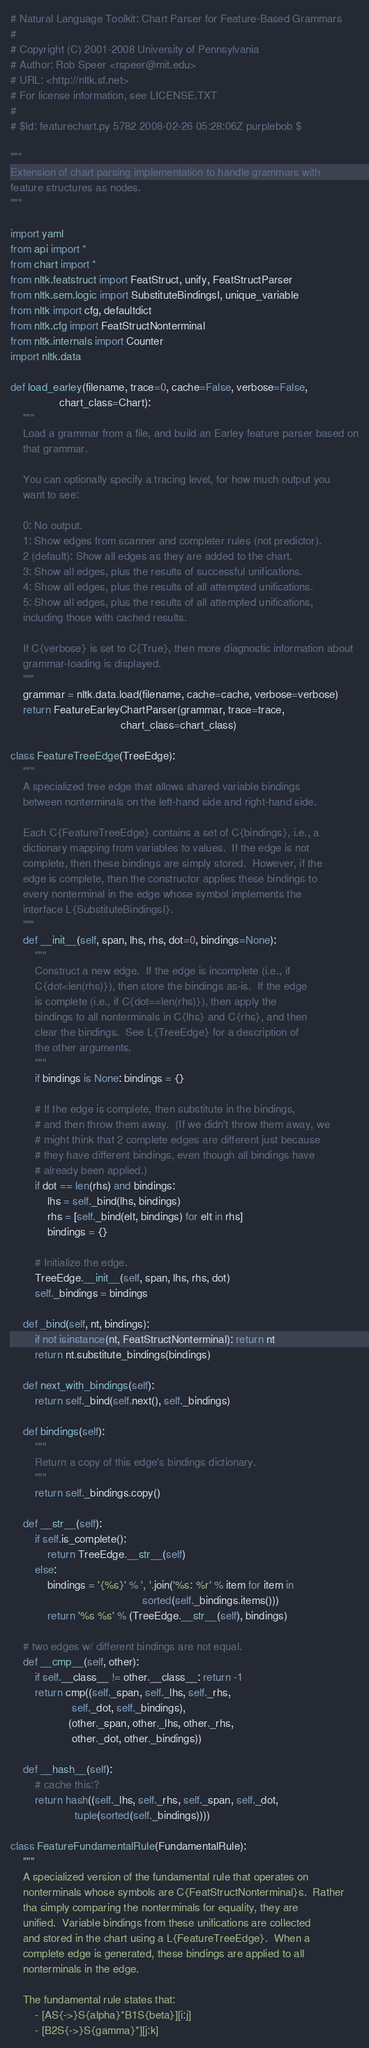<code> <loc_0><loc_0><loc_500><loc_500><_Python_># Natural Language Toolkit: Chart Parser for Feature-Based Grammars
#
# Copyright (C) 2001-2008 University of Pennsylvania
# Author: Rob Speer <rspeer@mit.edu>
# URL: <http://nltk.sf.net>
# For license information, see LICENSE.TXT
#
# $Id: featurechart.py 5782 2008-02-26 05:28:06Z purplebob $

"""
Extension of chart parsing implementation to handle grammars with
feature structures as nodes.
"""

import yaml
from api import *
from chart import *
from nltk.featstruct import FeatStruct, unify, FeatStructParser
from nltk.sem.logic import SubstituteBindingsI, unique_variable
from nltk import cfg, defaultdict
from nltk.cfg import FeatStructNonterminal
from nltk.internals import Counter
import nltk.data

def load_earley(filename, trace=0, cache=False, verbose=False,
                chart_class=Chart):
    """
    Load a grammar from a file, and build an Earley feature parser based on
    that grammar.

    You can optionally specify a tracing level, for how much output you
    want to see:

    0: No output.
    1: Show edges from scanner and completer rules (not predictor).
    2 (default): Show all edges as they are added to the chart.
    3: Show all edges, plus the results of successful unifications.
    4: Show all edges, plus the results of all attempted unifications.
    5: Show all edges, plus the results of all attempted unifications,
    including those with cached results.

    If C{verbose} is set to C{True}, then more diagnostic information about
    grammar-loading is displayed.
    """
    grammar = nltk.data.load(filename, cache=cache, verbose=verbose)
    return FeatureEarleyChartParser(grammar, trace=trace,
                                    chart_class=chart_class)

class FeatureTreeEdge(TreeEdge):
    """
    A specialized tree edge that allows shared variable bindings
    between nonterminals on the left-hand side and right-hand side.

    Each C{FeatureTreeEdge} contains a set of C{bindings}, i.e., a
    dictionary mapping from variables to values.  If the edge is not
    complete, then these bindings are simply stored.  However, if the
    edge is complete, then the constructor applies these bindings to
    every nonterminal in the edge whose symbol implements the
    interface L{SubstituteBindingsI}.
    """
    def __init__(self, span, lhs, rhs, dot=0, bindings=None):
        """
        Construct a new edge.  If the edge is incomplete (i.e., if
        C{dot<len(rhs)}), then store the bindings as-is.  If the edge
        is complete (i.e., if C{dot==len(rhs)}), then apply the
        bindings to all nonterminals in C{lhs} and C{rhs}, and then
        clear the bindings.  See L{TreeEdge} for a description of
        the other arguments.
        """
        if bindings is None: bindings = {}
        
        # If the edge is complete, then substitute in the bindings,
        # and then throw them away.  (If we didn't throw them away, we
        # might think that 2 complete edges are different just because
        # they have different bindings, even though all bindings have
        # already been applied.)
        if dot == len(rhs) and bindings:
            lhs = self._bind(lhs, bindings)
            rhs = [self._bind(elt, bindings) for elt in rhs]
            bindings = {}

        # Initialize the edge.
        TreeEdge.__init__(self, span, lhs, rhs, dot)
        self._bindings = bindings

    def _bind(self, nt, bindings):
        if not isinstance(nt, FeatStructNonterminal): return nt
        return nt.substitute_bindings(bindings)

    def next_with_bindings(self):
        return self._bind(self.next(), self._bindings)

    def bindings(self):
        """
        Return a copy of this edge's bindings dictionary.
        """
        return self._bindings.copy()

    def __str__(self):
        if self.is_complete():
            return TreeEdge.__str__(self)
        else:
            bindings = '{%s}' % ', '.join('%s: %r' % item for item in
                                           sorted(self._bindings.items()))
            return '%s %s' % (TreeEdge.__str__(self), bindings)

    # two edges w/ different bindings are not equal.
    def __cmp__(self, other):
        if self.__class__ != other.__class__: return -1
        return cmp((self._span, self._lhs, self._rhs,
                    self._dot, self._bindings),
                   (other._span, other._lhs, other._rhs,
                    other._dot, other._bindings))
    
    def __hash__(self):
        # cache this:?
        return hash((self._lhs, self._rhs, self._span, self._dot,
                     tuple(sorted(self._bindings))))
    
class FeatureFundamentalRule(FundamentalRule):
    """
    A specialized version of the fundamental rule that operates on
    nonterminals whose symbols are C{FeatStructNonterminal}s.  Rather
    tha simply comparing the nonterminals for equality, they are
    unified.  Variable bindings from these unifications are collected
    and stored in the chart using a L{FeatureTreeEdge}.  When a
    complete edge is generated, these bindings are applied to all
    nonterminals in the edge.

    The fundamental rule states that:
        - [AS{->}S{alpha}*B1S{beta}][i:j]
        - [B2S{->}S{gamma}*][j:k]</code> 